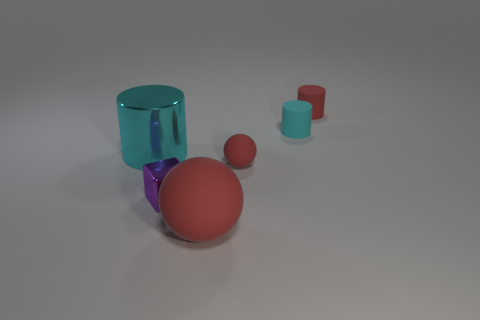Subtract all tiny matte cylinders. How many cylinders are left? 1 Add 1 red rubber blocks. How many objects exist? 7 Subtract all red cylinders. How many cylinders are left? 2 Subtract all cubes. How many objects are left? 5 Subtract all yellow cylinders. How many gray cubes are left? 0 Add 6 small cylinders. How many small cylinders are left? 8 Add 2 large cyan objects. How many large cyan objects exist? 3 Subtract 1 cyan cylinders. How many objects are left? 5 Subtract 1 spheres. How many spheres are left? 1 Subtract all brown cubes. Subtract all red spheres. How many cubes are left? 1 